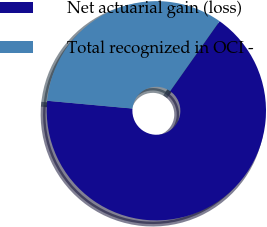Convert chart to OTSL. <chart><loc_0><loc_0><loc_500><loc_500><pie_chart><fcel>Net actuarial gain (loss)<fcel>Total recognized in OCI -<nl><fcel>66.67%<fcel>33.33%<nl></chart> 